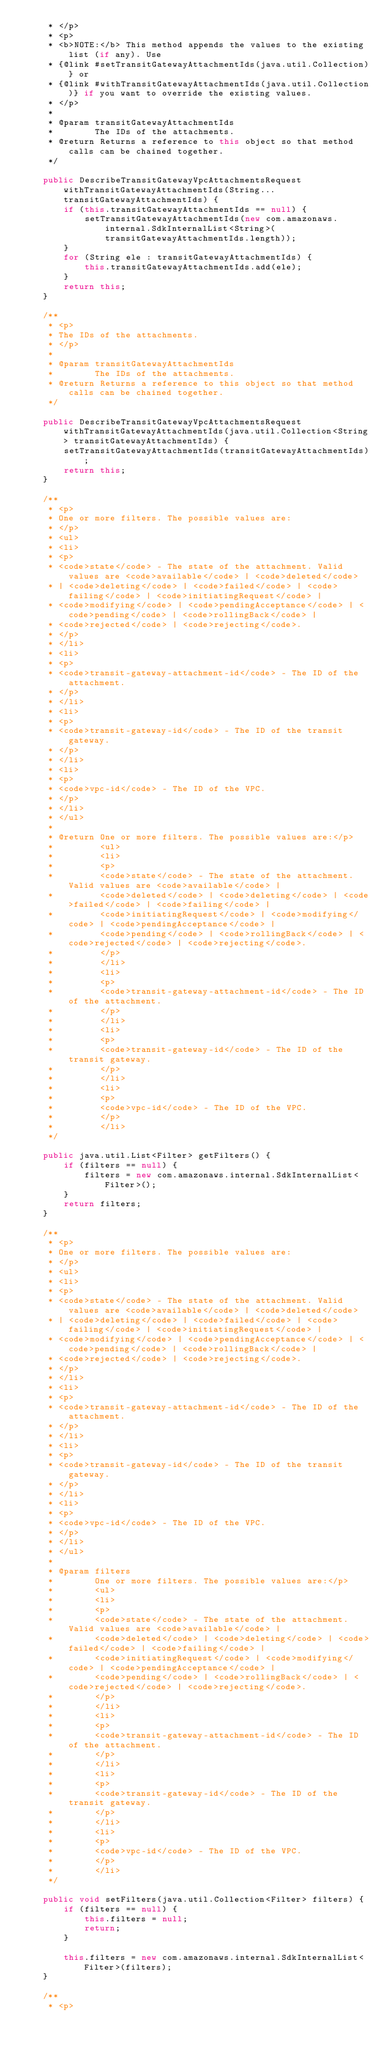<code> <loc_0><loc_0><loc_500><loc_500><_Java_>     * </p>
     * <p>
     * <b>NOTE:</b> This method appends the values to the existing list (if any). Use
     * {@link #setTransitGatewayAttachmentIds(java.util.Collection)} or
     * {@link #withTransitGatewayAttachmentIds(java.util.Collection)} if you want to override the existing values.
     * </p>
     * 
     * @param transitGatewayAttachmentIds
     *        The IDs of the attachments.
     * @return Returns a reference to this object so that method calls can be chained together.
     */

    public DescribeTransitGatewayVpcAttachmentsRequest withTransitGatewayAttachmentIds(String... transitGatewayAttachmentIds) {
        if (this.transitGatewayAttachmentIds == null) {
            setTransitGatewayAttachmentIds(new com.amazonaws.internal.SdkInternalList<String>(transitGatewayAttachmentIds.length));
        }
        for (String ele : transitGatewayAttachmentIds) {
            this.transitGatewayAttachmentIds.add(ele);
        }
        return this;
    }

    /**
     * <p>
     * The IDs of the attachments.
     * </p>
     * 
     * @param transitGatewayAttachmentIds
     *        The IDs of the attachments.
     * @return Returns a reference to this object so that method calls can be chained together.
     */

    public DescribeTransitGatewayVpcAttachmentsRequest withTransitGatewayAttachmentIds(java.util.Collection<String> transitGatewayAttachmentIds) {
        setTransitGatewayAttachmentIds(transitGatewayAttachmentIds);
        return this;
    }

    /**
     * <p>
     * One or more filters. The possible values are:
     * </p>
     * <ul>
     * <li>
     * <p>
     * <code>state</code> - The state of the attachment. Valid values are <code>available</code> | <code>deleted</code>
     * | <code>deleting</code> | <code>failed</code> | <code>failing</code> | <code>initiatingRequest</code> |
     * <code>modifying</code> | <code>pendingAcceptance</code> | <code>pending</code> | <code>rollingBack</code> |
     * <code>rejected</code> | <code>rejecting</code>.
     * </p>
     * </li>
     * <li>
     * <p>
     * <code>transit-gateway-attachment-id</code> - The ID of the attachment.
     * </p>
     * </li>
     * <li>
     * <p>
     * <code>transit-gateway-id</code> - The ID of the transit gateway.
     * </p>
     * </li>
     * <li>
     * <p>
     * <code>vpc-id</code> - The ID of the VPC.
     * </p>
     * </li>
     * </ul>
     * 
     * @return One or more filters. The possible values are:</p>
     *         <ul>
     *         <li>
     *         <p>
     *         <code>state</code> - The state of the attachment. Valid values are <code>available</code> |
     *         <code>deleted</code> | <code>deleting</code> | <code>failed</code> | <code>failing</code> |
     *         <code>initiatingRequest</code> | <code>modifying</code> | <code>pendingAcceptance</code> |
     *         <code>pending</code> | <code>rollingBack</code> | <code>rejected</code> | <code>rejecting</code>.
     *         </p>
     *         </li>
     *         <li>
     *         <p>
     *         <code>transit-gateway-attachment-id</code> - The ID of the attachment.
     *         </p>
     *         </li>
     *         <li>
     *         <p>
     *         <code>transit-gateway-id</code> - The ID of the transit gateway.
     *         </p>
     *         </li>
     *         <li>
     *         <p>
     *         <code>vpc-id</code> - The ID of the VPC.
     *         </p>
     *         </li>
     */

    public java.util.List<Filter> getFilters() {
        if (filters == null) {
            filters = new com.amazonaws.internal.SdkInternalList<Filter>();
        }
        return filters;
    }

    /**
     * <p>
     * One or more filters. The possible values are:
     * </p>
     * <ul>
     * <li>
     * <p>
     * <code>state</code> - The state of the attachment. Valid values are <code>available</code> | <code>deleted</code>
     * | <code>deleting</code> | <code>failed</code> | <code>failing</code> | <code>initiatingRequest</code> |
     * <code>modifying</code> | <code>pendingAcceptance</code> | <code>pending</code> | <code>rollingBack</code> |
     * <code>rejected</code> | <code>rejecting</code>.
     * </p>
     * </li>
     * <li>
     * <p>
     * <code>transit-gateway-attachment-id</code> - The ID of the attachment.
     * </p>
     * </li>
     * <li>
     * <p>
     * <code>transit-gateway-id</code> - The ID of the transit gateway.
     * </p>
     * </li>
     * <li>
     * <p>
     * <code>vpc-id</code> - The ID of the VPC.
     * </p>
     * </li>
     * </ul>
     * 
     * @param filters
     *        One or more filters. The possible values are:</p>
     *        <ul>
     *        <li>
     *        <p>
     *        <code>state</code> - The state of the attachment. Valid values are <code>available</code> |
     *        <code>deleted</code> | <code>deleting</code> | <code>failed</code> | <code>failing</code> |
     *        <code>initiatingRequest</code> | <code>modifying</code> | <code>pendingAcceptance</code> |
     *        <code>pending</code> | <code>rollingBack</code> | <code>rejected</code> | <code>rejecting</code>.
     *        </p>
     *        </li>
     *        <li>
     *        <p>
     *        <code>transit-gateway-attachment-id</code> - The ID of the attachment.
     *        </p>
     *        </li>
     *        <li>
     *        <p>
     *        <code>transit-gateway-id</code> - The ID of the transit gateway.
     *        </p>
     *        </li>
     *        <li>
     *        <p>
     *        <code>vpc-id</code> - The ID of the VPC.
     *        </p>
     *        </li>
     */

    public void setFilters(java.util.Collection<Filter> filters) {
        if (filters == null) {
            this.filters = null;
            return;
        }

        this.filters = new com.amazonaws.internal.SdkInternalList<Filter>(filters);
    }

    /**
     * <p></code> 